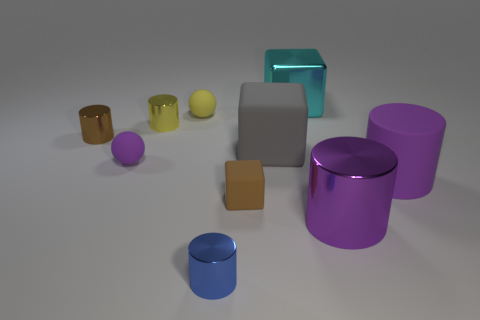Subtract all yellow cylinders. How many cylinders are left? 4 Subtract 2 cylinders. How many cylinders are left? 3 Subtract all yellow cylinders. How many cylinders are left? 4 Subtract all green cylinders. Subtract all red blocks. How many cylinders are left? 5 Subtract all spheres. How many objects are left? 8 Add 9 tiny yellow balls. How many tiny yellow balls are left? 10 Add 6 small brown rubber cubes. How many small brown rubber cubes exist? 7 Subtract 0 blue spheres. How many objects are left? 10 Subtract all brown metal cylinders. Subtract all big purple things. How many objects are left? 7 